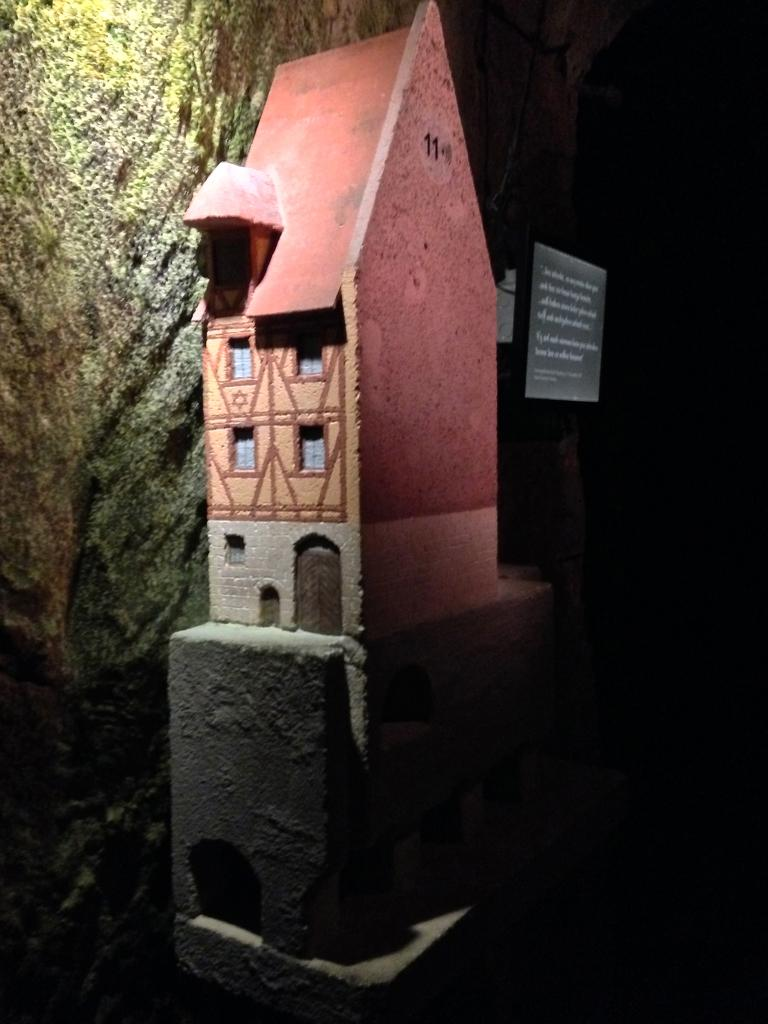What type of structure is visible in the image? There is a building in the image. What is located behind the building? There is a board behind the building. What can be seen on the opposite side of the building in the image? There is a stone wall on the backside of the image. What form of anger is displayed by the building in the image? There is no indication of anger in the image, as buildings are inanimate objects and cannot display emotions. 